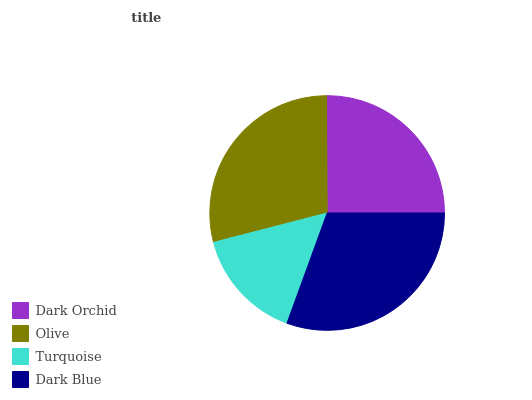Is Turquoise the minimum?
Answer yes or no. Yes. Is Dark Blue the maximum?
Answer yes or no. Yes. Is Olive the minimum?
Answer yes or no. No. Is Olive the maximum?
Answer yes or no. No. Is Olive greater than Dark Orchid?
Answer yes or no. Yes. Is Dark Orchid less than Olive?
Answer yes or no. Yes. Is Dark Orchid greater than Olive?
Answer yes or no. No. Is Olive less than Dark Orchid?
Answer yes or no. No. Is Olive the high median?
Answer yes or no. Yes. Is Dark Orchid the low median?
Answer yes or no. Yes. Is Dark Orchid the high median?
Answer yes or no. No. Is Turquoise the low median?
Answer yes or no. No. 